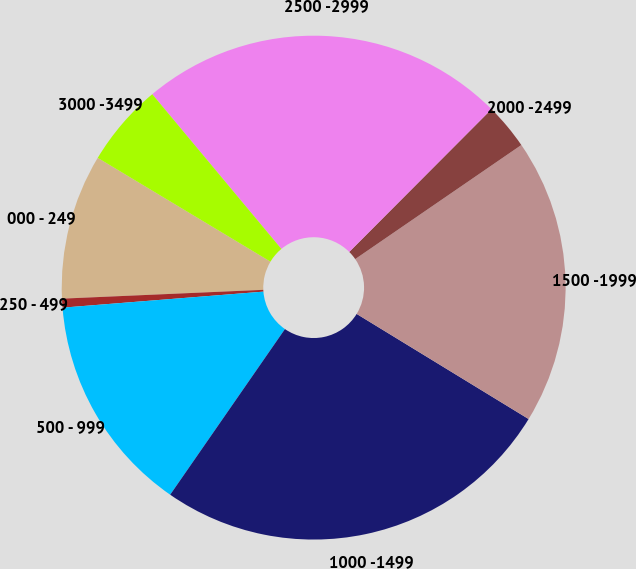<chart> <loc_0><loc_0><loc_500><loc_500><pie_chart><fcel>000 - 249<fcel>250 - 499<fcel>500 - 999<fcel>1000 -1499<fcel>1500 -1999<fcel>2000 -2499<fcel>2500 -2999<fcel>3000 -3499<nl><fcel>9.31%<fcel>0.57%<fcel>14.09%<fcel>25.91%<fcel>18.31%<fcel>2.95%<fcel>23.54%<fcel>5.32%<nl></chart> 